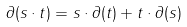Convert formula to latex. <formula><loc_0><loc_0><loc_500><loc_500>\partial ( s \cdot t ) = s \cdot \partial ( t ) + t \cdot \partial ( s )</formula> 